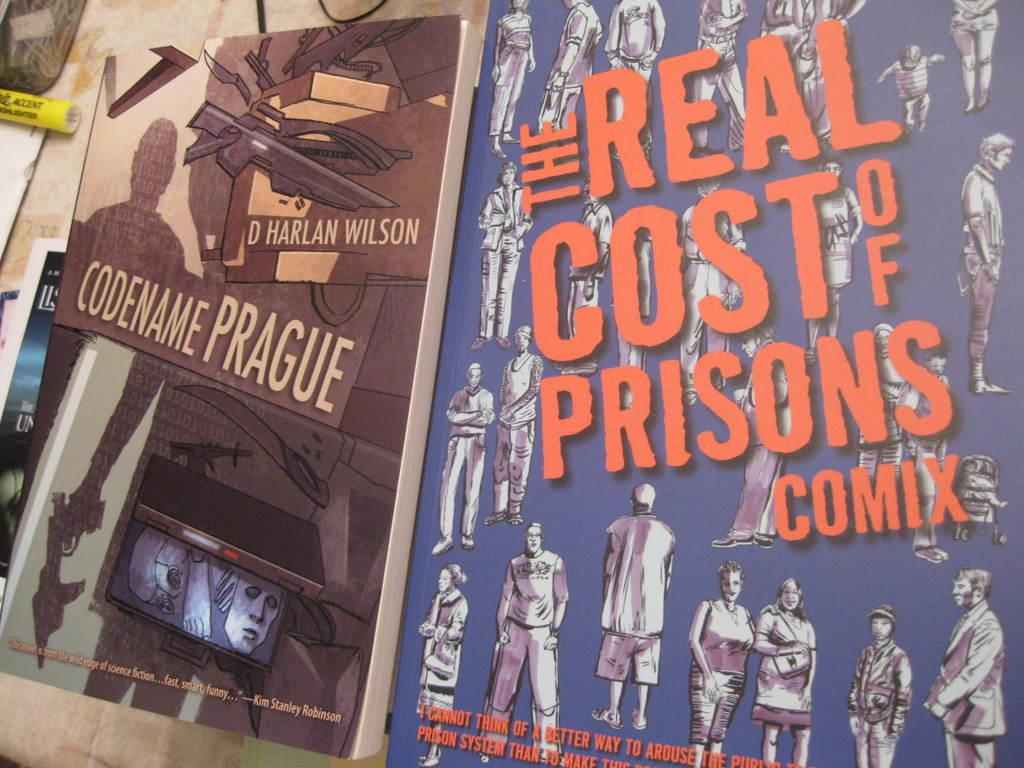Provide a one-sentence caption for the provided image. Two posters are displayed featuring "Codename Prague" and "The real cost of prisons comix". 